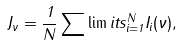<formula> <loc_0><loc_0><loc_500><loc_500>J _ { \nu } = \frac { 1 } { N } \sum \lim i t s _ { i = 1 } ^ { N } I _ { i } ( \nu ) ,</formula> 